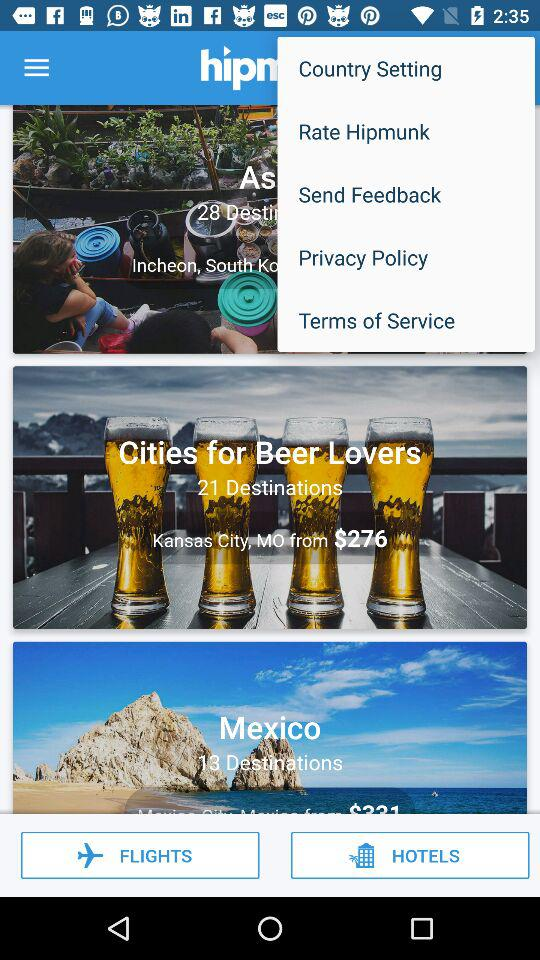What is the amount? The amount is $276. 